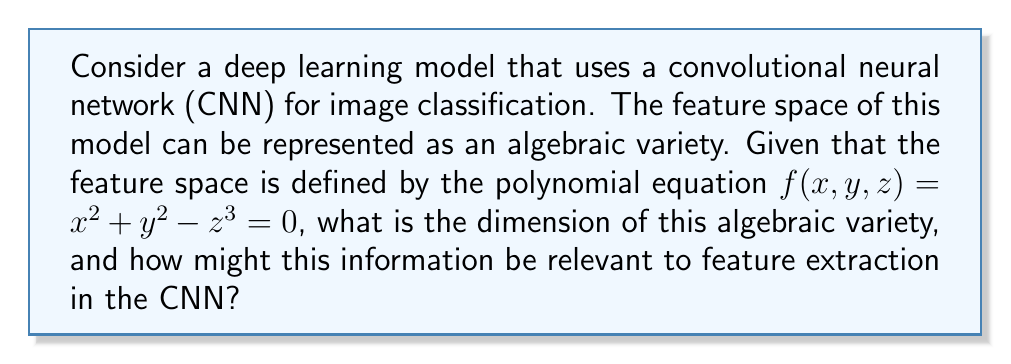Solve this math problem. To solve this problem, we'll follow these steps:

1) First, we need to understand what an algebraic variety is. An algebraic variety is the set of solutions of a system of polynomial equations. In this case, we have a single equation $f(x, y, z) = x^2 + y^2 - z^3 = 0$.

2) The dimension of an algebraic variety is typically defined as the number of free parameters needed to describe a general point on the variety. In other words, it's the number of variables minus the number of independent equations.

3) In our case, we have 3 variables (x, y, z) and 1 equation. Therefore, the dimension is:

   $\text{dim} = \text{number of variables} - \text{number of independent equations} = 3 - 1 = 2$

4) This means our algebraic variety is a 2-dimensional surface in 3-dimensional space. Geometrically, this surface is known as a "cusp".

5) In the context of CNNs and feature extraction:

   a) The dimension of the algebraic variety corresponds to the intrinsic dimensionality of the feature space. A lower-dimensional feature space often indicates more efficient feature extraction.

   b) The shape of the variety (in this case, a cusp) can provide insights into the structure of the feature space. For example, the cusp has a singular point at the origin, which might correspond to a particularly important or distinctive feature.

   c) Understanding the geometry of the feature space can help in designing more effective CNN architectures or in interpreting the learned features.

   d) The polynomial defining the variety could be seen as a constraint on the possible features, potentially guiding the feature extraction process or helping to avoid overfitting.

6) For a software engineer working on machine learning projects, this understanding could be valuable when designing or optimizing CNN architectures, or when interpreting the results of feature extraction processes.
Answer: 2 